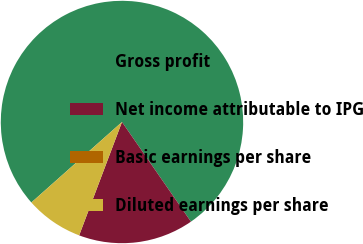<chart> <loc_0><loc_0><loc_500><loc_500><pie_chart><fcel>Gross profit<fcel>Net income attributable to IPG<fcel>Basic earnings per share<fcel>Diluted earnings per share<nl><fcel>76.92%<fcel>15.38%<fcel>0.0%<fcel>7.69%<nl></chart> 